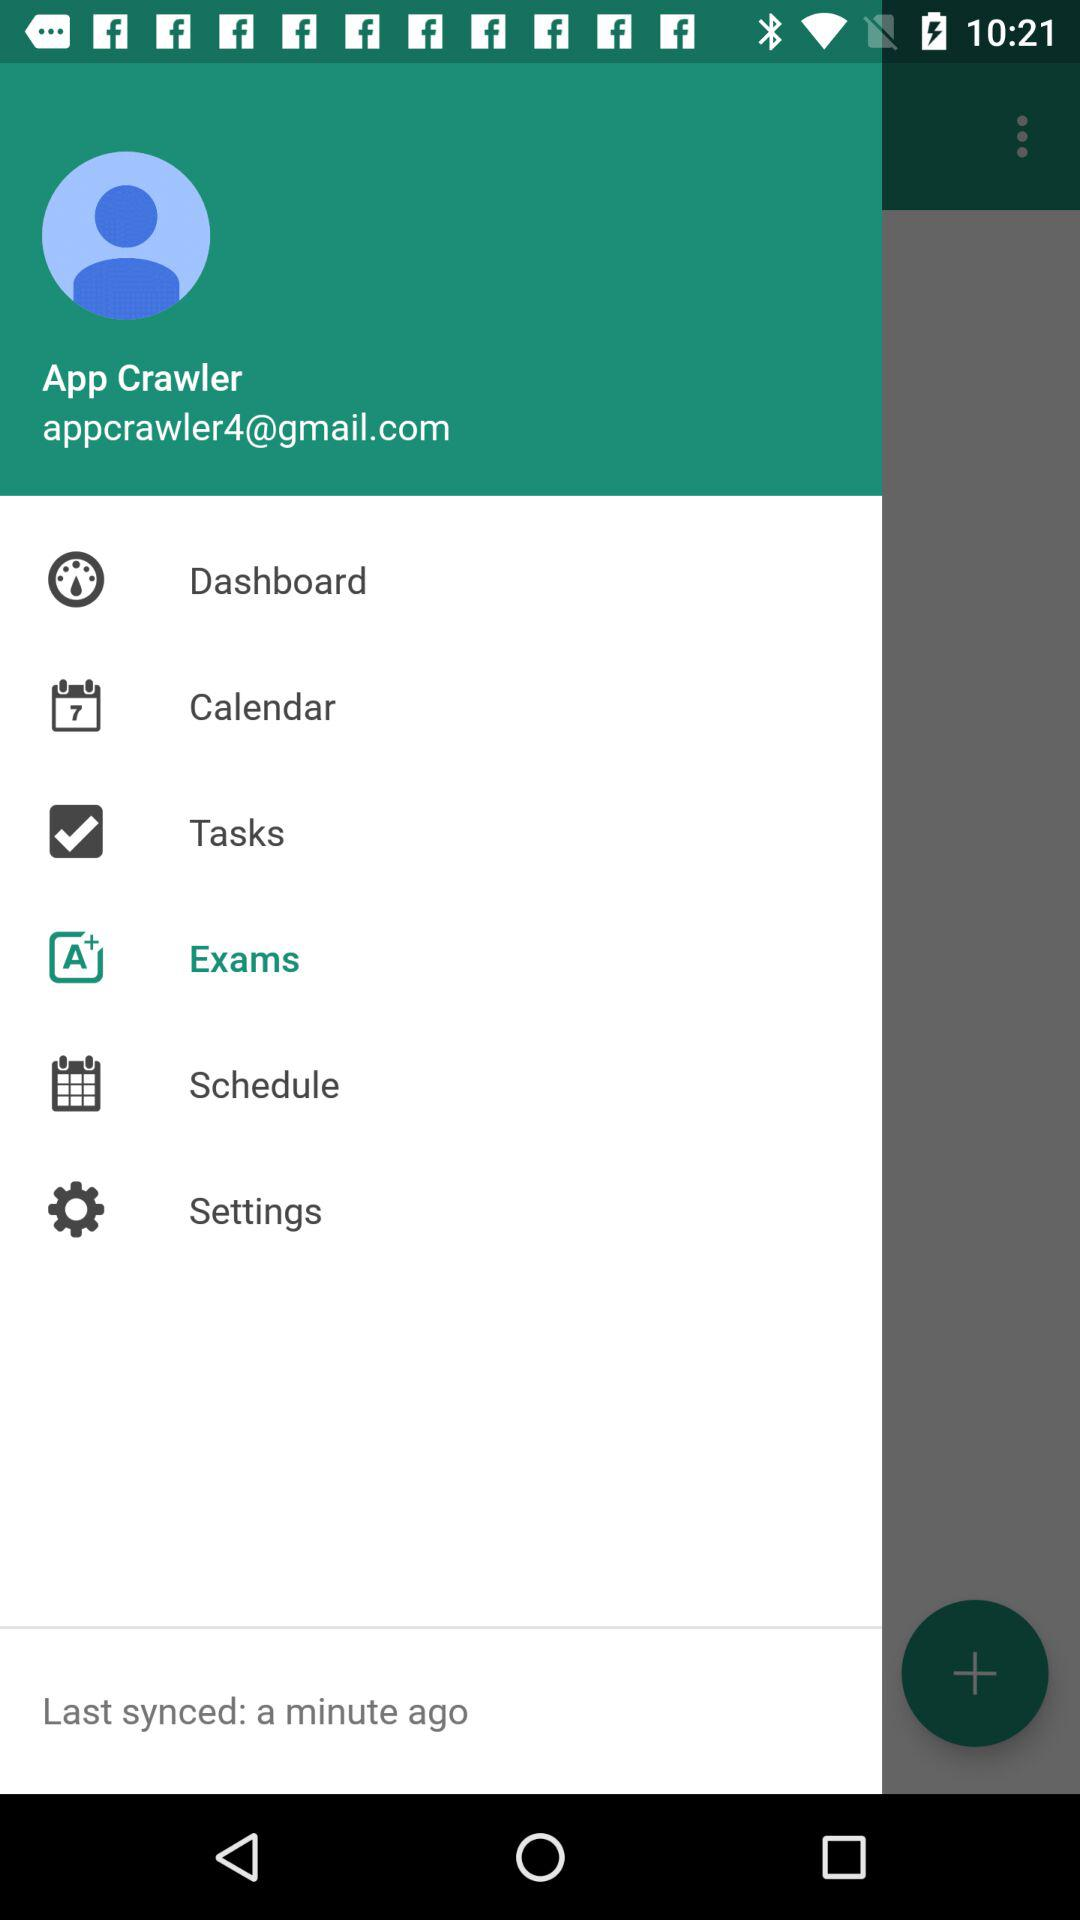What is the checked option? The checked option is "Tasks". 